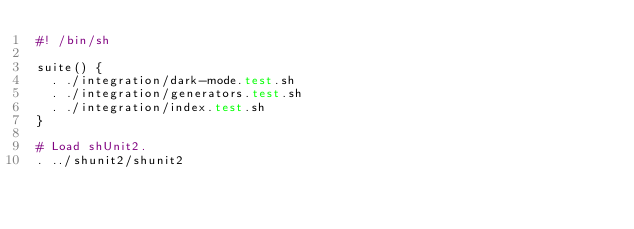<code> <loc_0><loc_0><loc_500><loc_500><_Bash_>#! /bin/sh

suite() {
  . ./integration/dark-mode.test.sh
  . ./integration/generators.test.sh
  . ./integration/index.test.sh
}

# Load shUnit2.
. ../shunit2/shunit2
</code> 